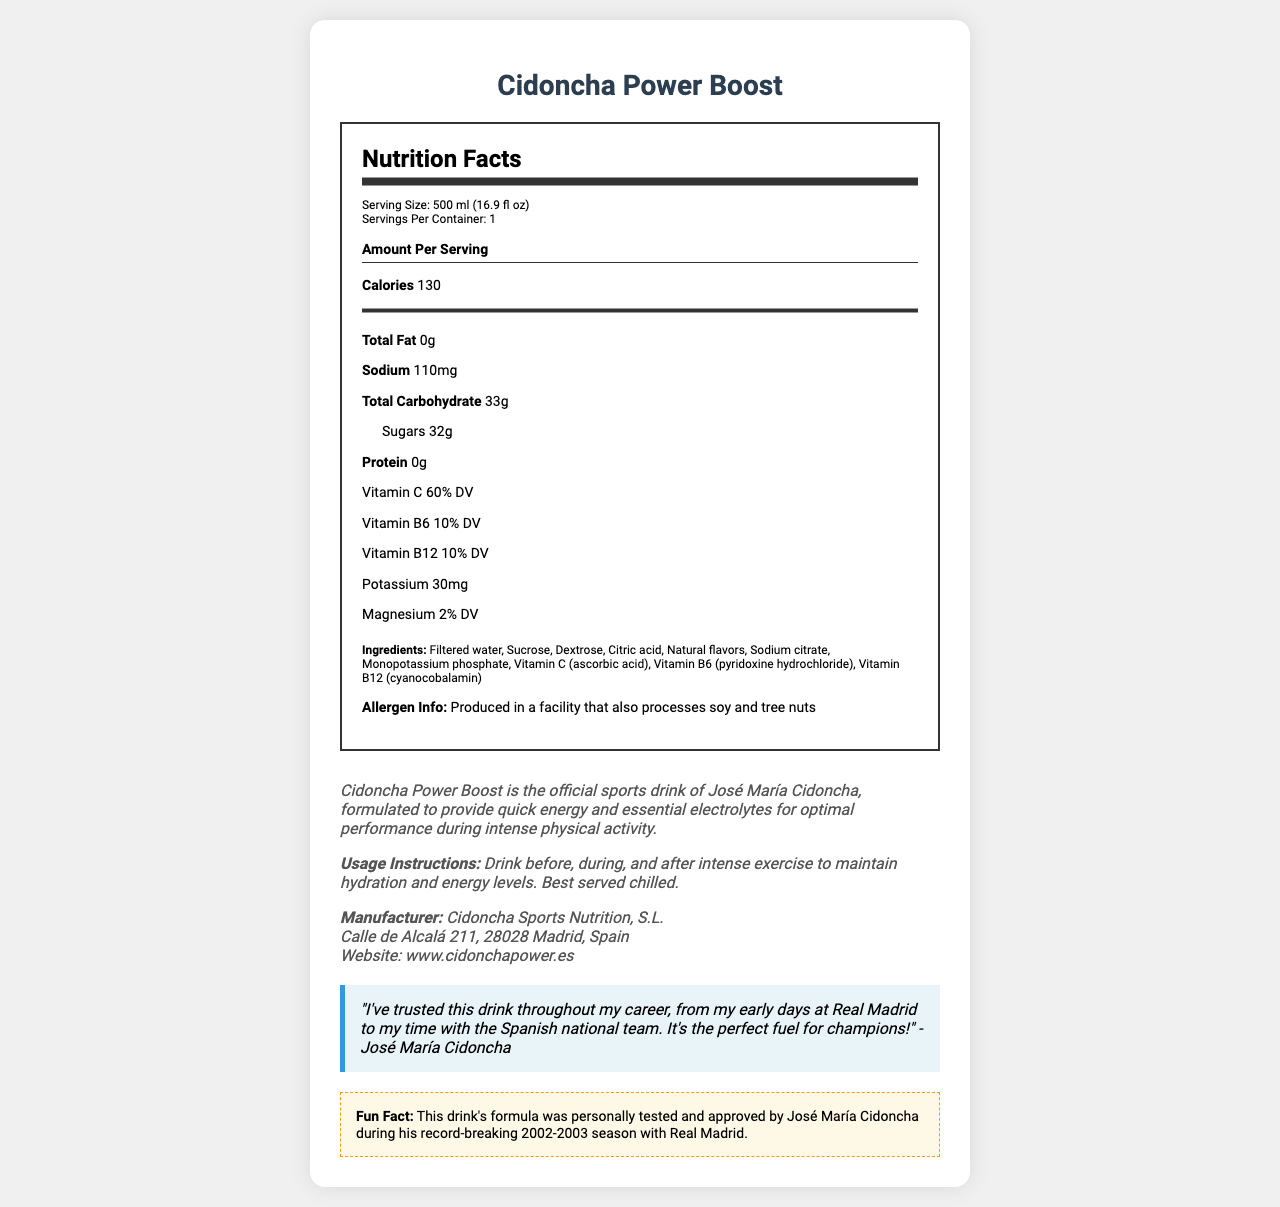what is the serving size? The serving size is listed under the "Serving Size" section as 500 ml (16.9 fl oz).
Answer: 500 ml (16.9 fl oz) what is the amount of sodium per serving? The sodium content per serving is listed as 110 mg in the "Amount Per Serving" section.
Answer: 110 mg how many grams of sugar are in one serving? The sugar content is listed under "Sugars" as 32 g per serving.
Answer: 32 g how many calories are there in one container? The calories per serving are listed as 130 in the "Amount Per Serving" section, and there is one serving per container.
Answer: 130 name the vitamins included and their daily values (DV) The vitamins and their daily values are listed under the "daily value" section.
Answer: Vitamin C (60% DV), Vitamin B6 (10% DV), Vitamin B12 (10% DV) who is the manufacturer of Cidoncha Power Boost? The manufacturer is listed in the "Manufacturer" section as Cidoncha Sports Nutrition, S.L.
Answer: Cidoncha Sports Nutrition, S.L. where is the company located? The address is listed in the "Manufacturer" section.
Answer: Calle de Alcalá 211, 28028 Madrid, Spain what is the website for more information? The website for more information is provided as www.cidonchapower.es.
Answer: www.cidonchapower.es which ingredient is used for sweetening? A. Aspartame B. Sucrose C. Stevia D. Sucralose Sucrose is listed among the ingredients, while the other options are not included.
Answer: B. Sucrose how much potassium is provided in one serving? A. 10 mg B. 20 mg C. 30 mg D. 40 mg Potassium content is listed as 30 mg under the "daily value" section.
Answer: C. 30 mg is this sports drink suitable for someone with a soy allergy? Yes/No The allergen information states it is produced in a facility that processes soy, which might pose a risk for someone with a soy allergy.
Answer: No describe the purpose of the Cidoncha Power Boost drink. The product description states that the drink is formulated to provide quick energy and essential electrolytes for optimal performance during intense physical activity.
Answer: Cidoncha Power Boost is designed to provide quick energy and essential electrolytes for optimal performance during intense physical activity. which season did José María Cidoncha test and approve the drink's formula? The fun fact section mentions that the formula was personally tested and approved by José María Cidoncha during his record-breaking 2002-2003 season with Real Madrid.
Answer: 2002-2003 season how much magnesium does one serving of Cidoncha Power Boost provide? The "daily value" section lists magnesium content as 2% DV.
Answer: 2% DV what flavors are used in the Cidoncha Power Boost drink? The ingredients section lists "Natural flavors," and no specific type of flavor is detailed.
Answer: Natural flavors what is the main idea of this document? The document is an advertisement for Cidoncha Power Boost, giving comprehensive information on its nutrition, ingredients, manufacturer details, and endorsements, focusing on its benefits for athletes.
Answer: The document provides details about Cidoncha Power Boost, including its nutrition facts, ingredients, manufacturer, usage instructions, and endorsement by José María Cidoncha. It highlights the drink's purpose for quick energy and electrolyte replenishment. what year did José María Cidoncha start his career? The document does not provide information about the exact year when José María Cidoncha started his career.
Answer: I don't know 